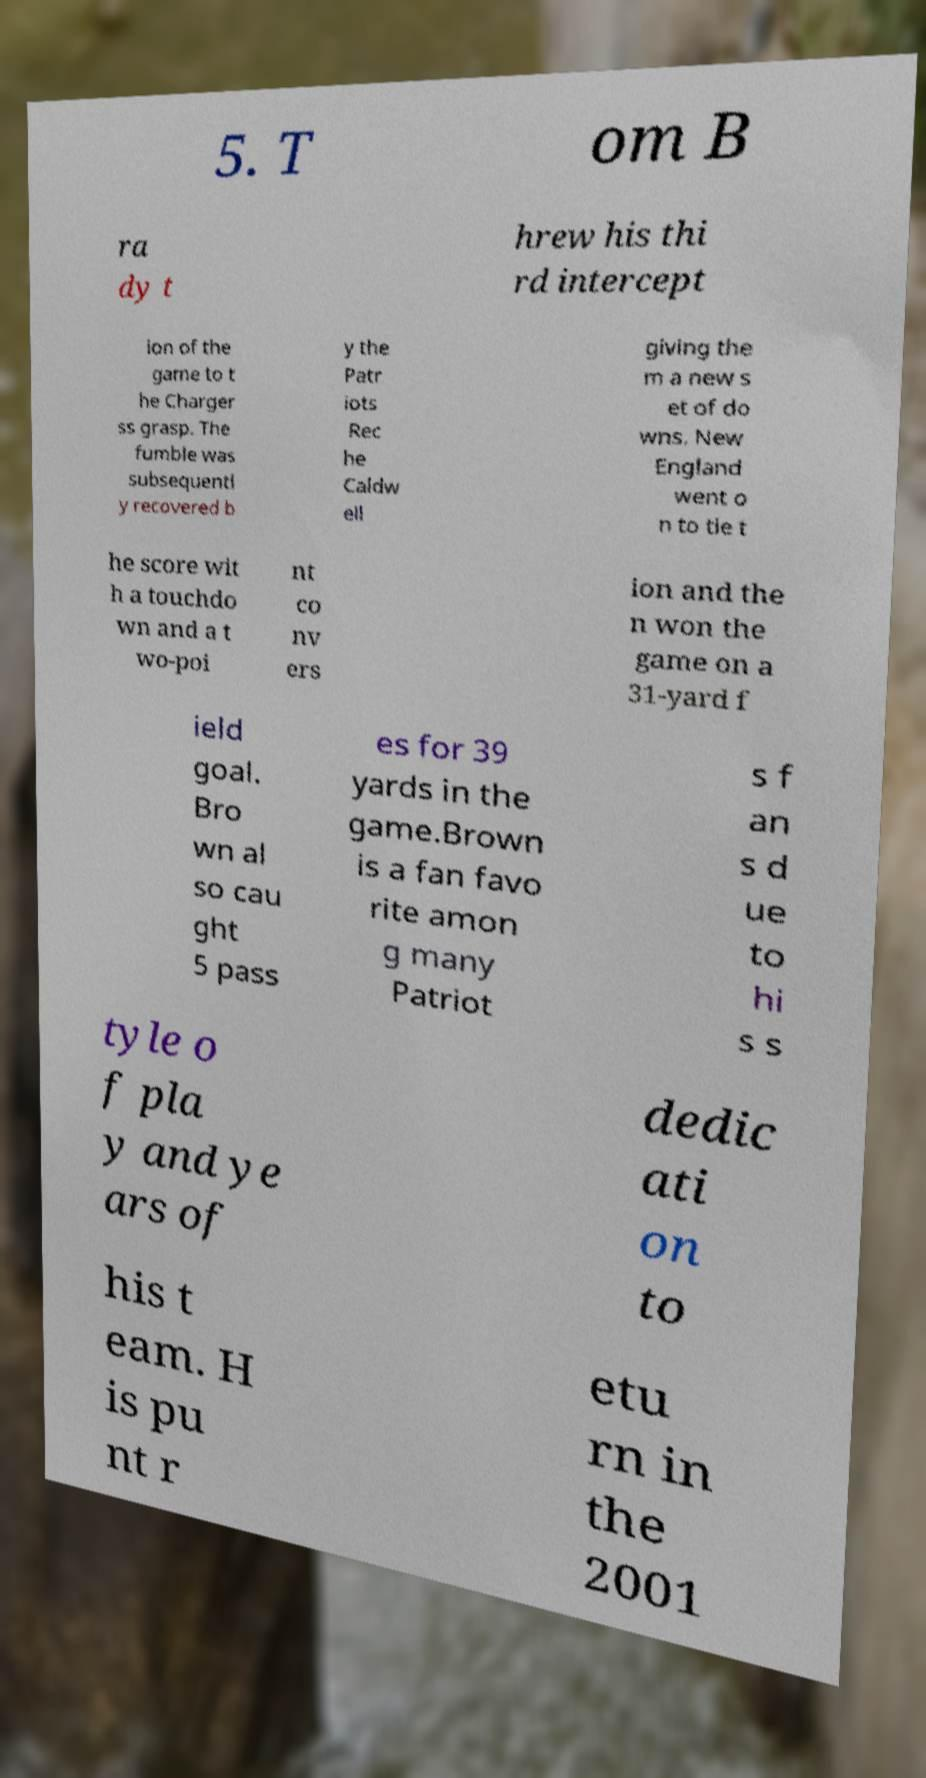Could you extract and type out the text from this image? 5. T om B ra dy t hrew his thi rd intercept ion of the game to t he Charger ss grasp. The fumble was subsequentl y recovered b y the Patr iots Rec he Caldw ell giving the m a new s et of do wns. New England went o n to tie t he score wit h a touchdo wn and a t wo-poi nt co nv ers ion and the n won the game on a 31-yard f ield goal. Bro wn al so cau ght 5 pass es for 39 yards in the game.Brown is a fan favo rite amon g many Patriot s f an s d ue to hi s s tyle o f pla y and ye ars of dedic ati on to his t eam. H is pu nt r etu rn in the 2001 